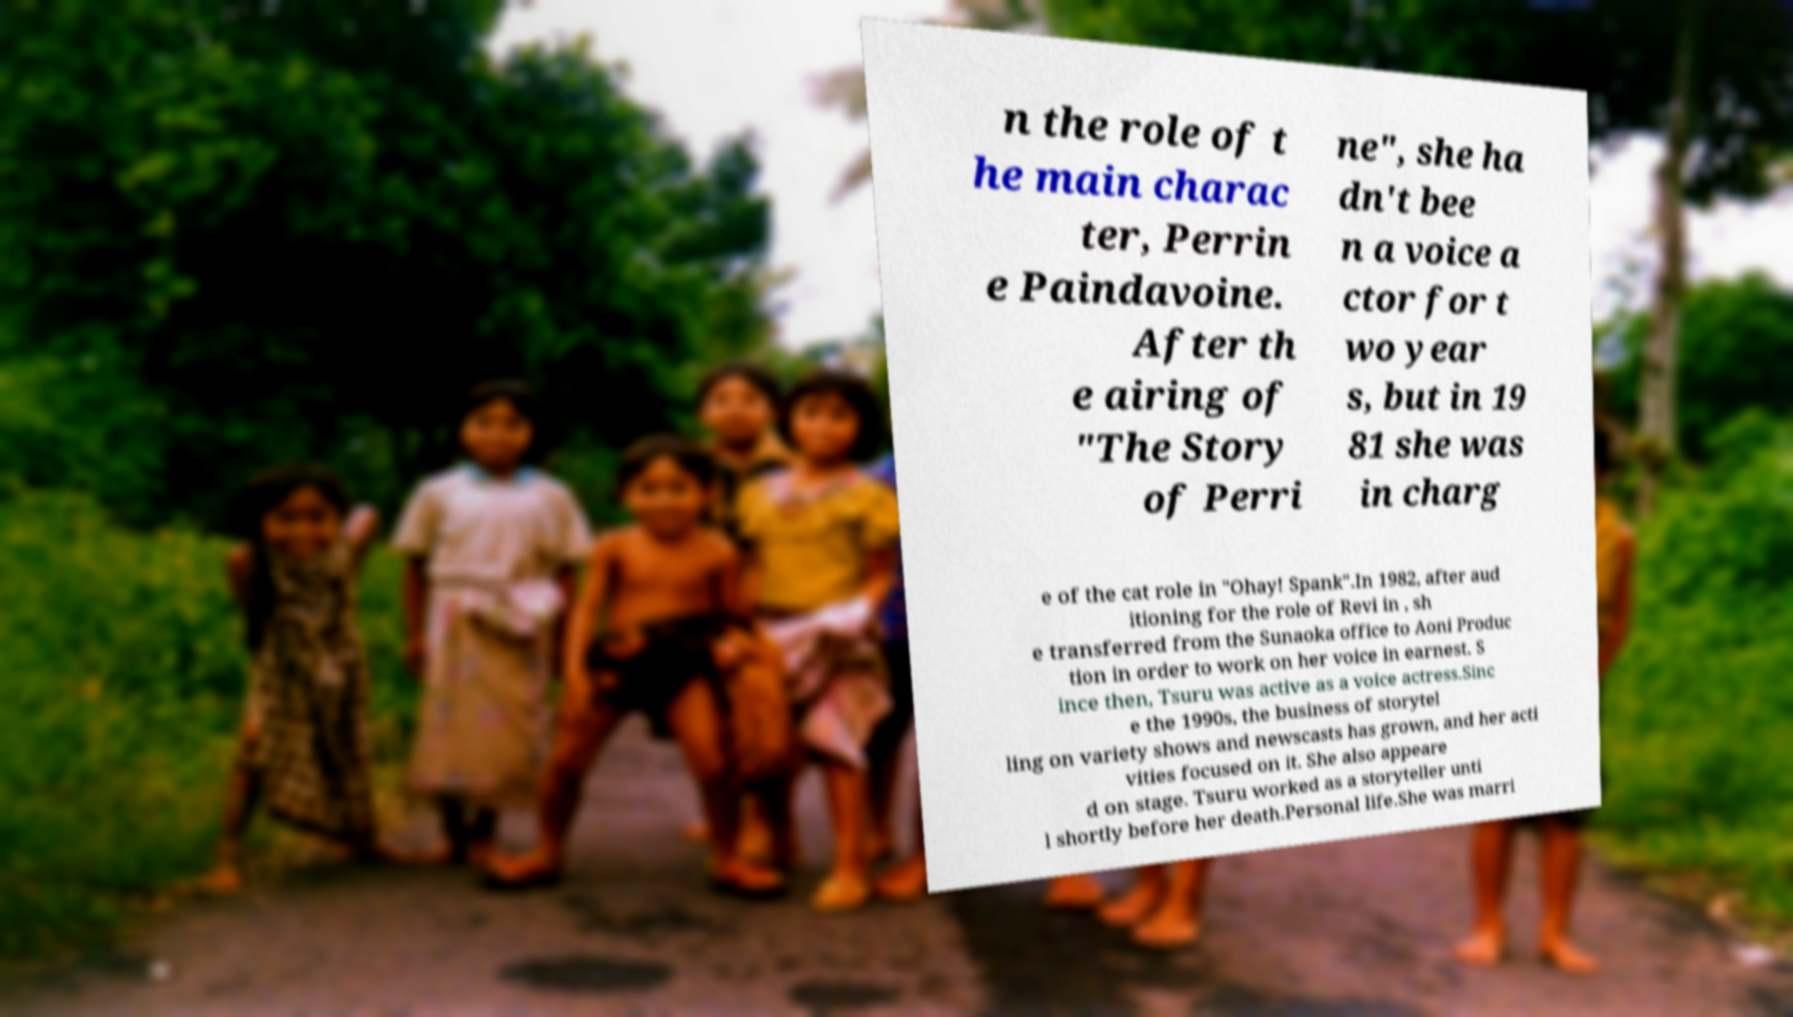I need the written content from this picture converted into text. Can you do that? n the role of t he main charac ter, Perrin e Paindavoine. After th e airing of "The Story of Perri ne", she ha dn't bee n a voice a ctor for t wo year s, but in 19 81 she was in charg e of the cat role in "Ohay! Spank".In 1982, after aud itioning for the role of Revi in , sh e transferred from the Sunaoka office to Aoni Produc tion in order to work on her voice in earnest. S ince then, Tsuru was active as a voice actress.Sinc e the 1990s, the business of storytel ling on variety shows and newscasts has grown, and her acti vities focused on it. She also appeare d on stage. Tsuru worked as a storyteller unti l shortly before her death.Personal life.She was marri 